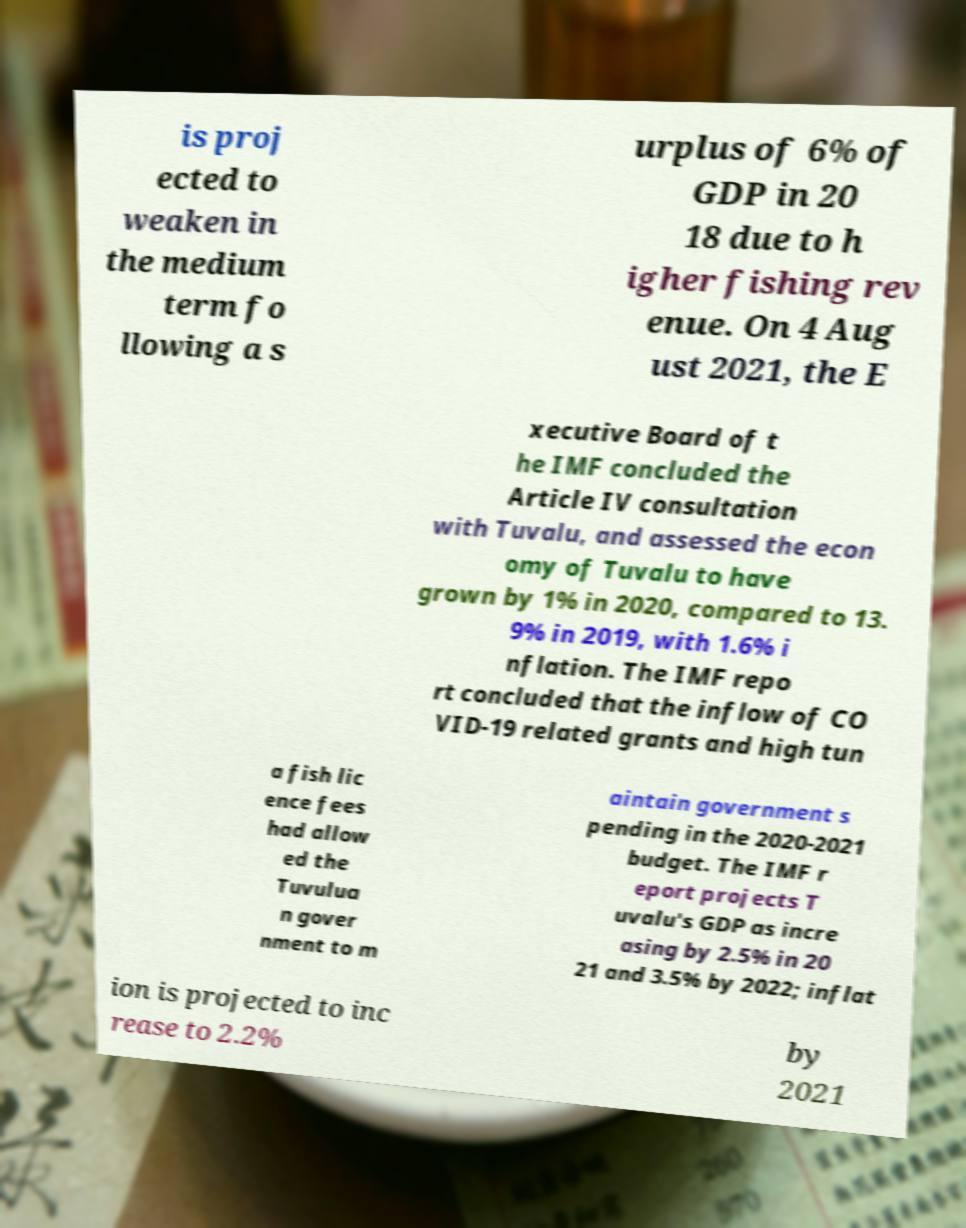Could you assist in decoding the text presented in this image and type it out clearly? is proj ected to weaken in the medium term fo llowing a s urplus of 6% of GDP in 20 18 due to h igher fishing rev enue. On 4 Aug ust 2021, the E xecutive Board of t he IMF concluded the Article IV consultation with Tuvalu, and assessed the econ omy of Tuvalu to have grown by 1% in 2020, compared to 13. 9% in 2019, with 1.6% i nflation. The IMF repo rt concluded that the inflow of CO VID-19 related grants and high tun a fish lic ence fees had allow ed the Tuvulua n gover nment to m aintain government s pending in the 2020-2021 budget. The IMF r eport projects T uvalu's GDP as incre asing by 2.5% in 20 21 and 3.5% by 2022; inflat ion is projected to inc rease to 2.2% by 2021 